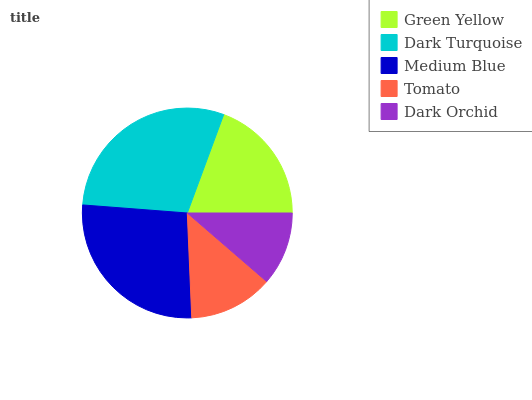Is Dark Orchid the minimum?
Answer yes or no. Yes. Is Dark Turquoise the maximum?
Answer yes or no. Yes. Is Medium Blue the minimum?
Answer yes or no. No. Is Medium Blue the maximum?
Answer yes or no. No. Is Dark Turquoise greater than Medium Blue?
Answer yes or no. Yes. Is Medium Blue less than Dark Turquoise?
Answer yes or no. Yes. Is Medium Blue greater than Dark Turquoise?
Answer yes or no. No. Is Dark Turquoise less than Medium Blue?
Answer yes or no. No. Is Green Yellow the high median?
Answer yes or no. Yes. Is Green Yellow the low median?
Answer yes or no. Yes. Is Dark Turquoise the high median?
Answer yes or no. No. Is Medium Blue the low median?
Answer yes or no. No. 